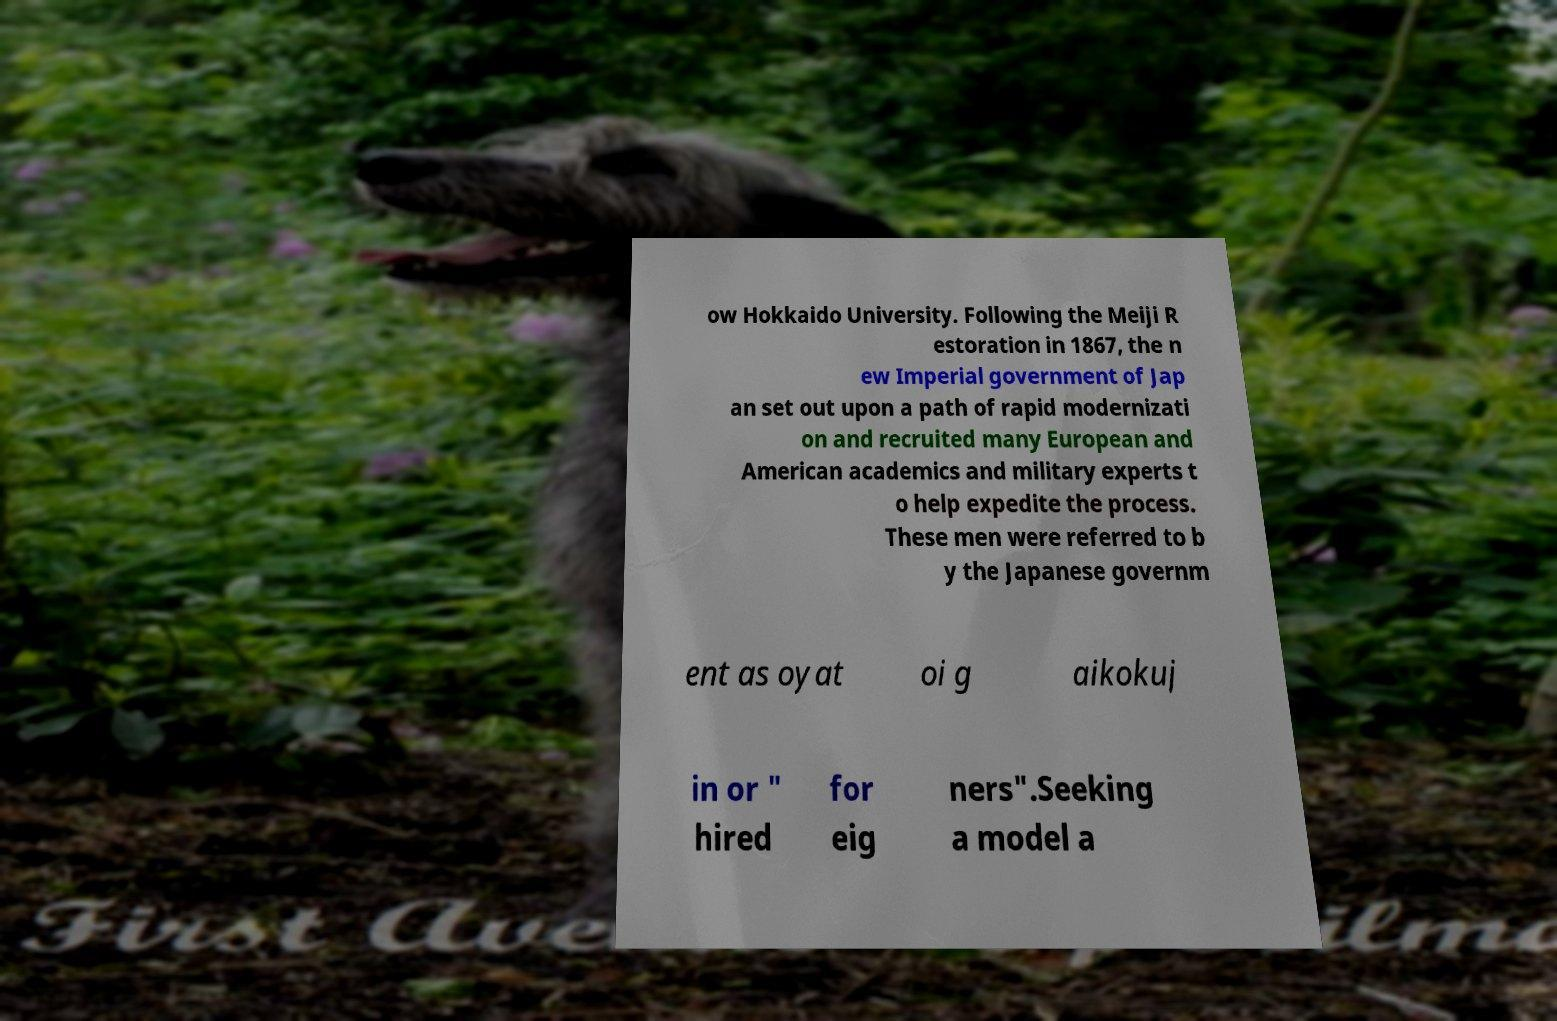Can you accurately transcribe the text from the provided image for me? ow Hokkaido University. Following the Meiji R estoration in 1867, the n ew Imperial government of Jap an set out upon a path of rapid modernizati on and recruited many European and American academics and military experts t o help expedite the process. These men were referred to b y the Japanese governm ent as oyat oi g aikokuj in or " hired for eig ners".Seeking a model a 